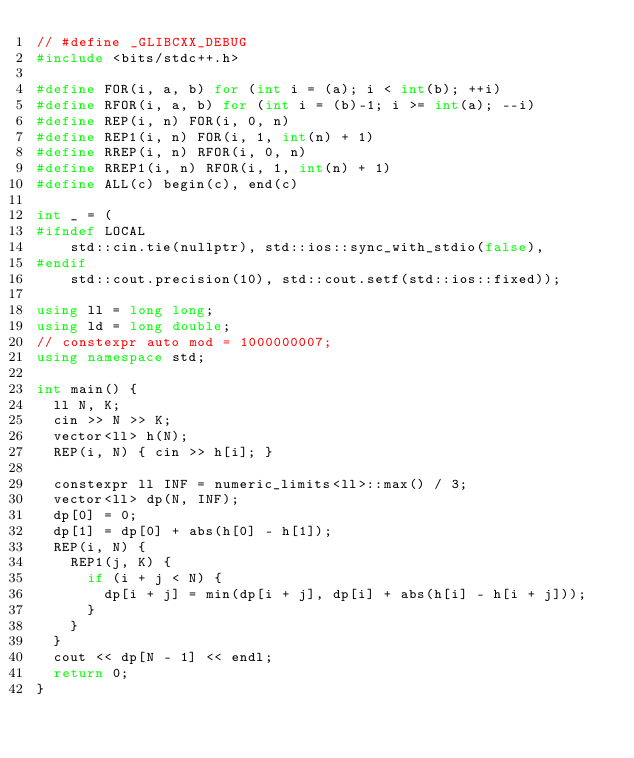Convert code to text. <code><loc_0><loc_0><loc_500><loc_500><_C++_>// #define _GLIBCXX_DEBUG
#include <bits/stdc++.h>

#define FOR(i, a, b) for (int i = (a); i < int(b); ++i)
#define RFOR(i, a, b) for (int i = (b)-1; i >= int(a); --i)
#define REP(i, n) FOR(i, 0, n)
#define REP1(i, n) FOR(i, 1, int(n) + 1)
#define RREP(i, n) RFOR(i, 0, n)
#define RREP1(i, n) RFOR(i, 1, int(n) + 1)
#define ALL(c) begin(c), end(c)

int _ = (
#ifndef LOCAL
    std::cin.tie(nullptr), std::ios::sync_with_stdio(false),
#endif
    std::cout.precision(10), std::cout.setf(std::ios::fixed));

using ll = long long;
using ld = long double;
// constexpr auto mod = 1000000007;
using namespace std;

int main() {
  ll N, K;
  cin >> N >> K;
  vector<ll> h(N);
  REP(i, N) { cin >> h[i]; }

  constexpr ll INF = numeric_limits<ll>::max() / 3;
  vector<ll> dp(N, INF);
  dp[0] = 0;
  dp[1] = dp[0] + abs(h[0] - h[1]);
  REP(i, N) {
    REP1(j, K) {
      if (i + j < N) {
        dp[i + j] = min(dp[i + j], dp[i] + abs(h[i] - h[i + j]));
      }
    }
  }
  cout << dp[N - 1] << endl;
  return 0;
}
</code> 